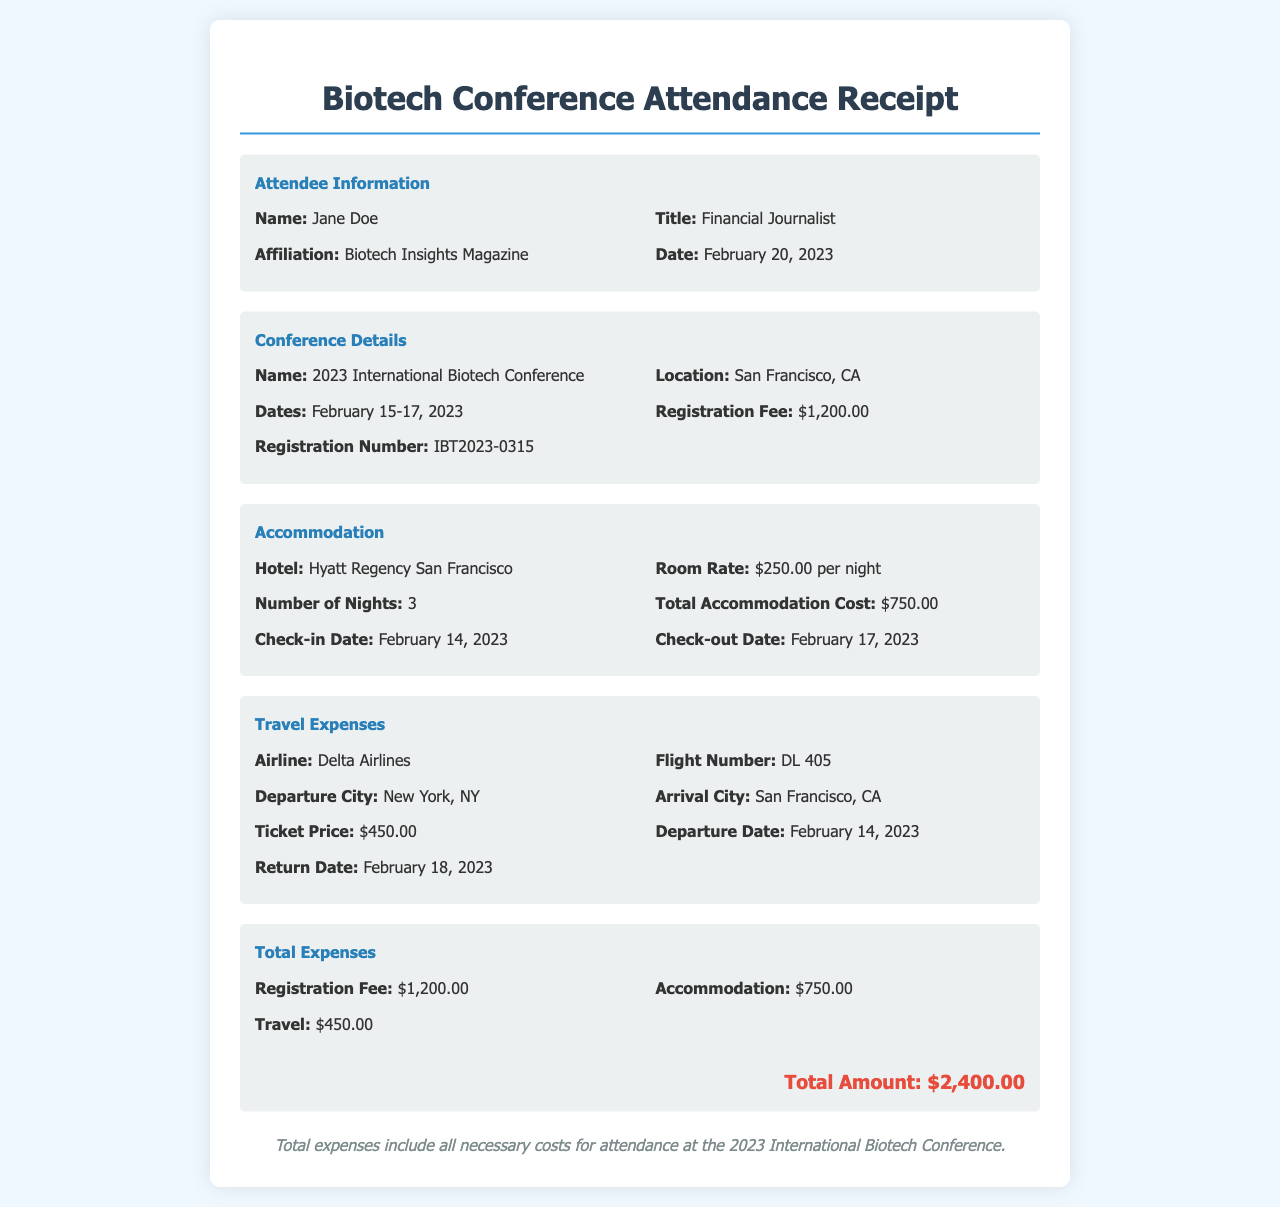what is the name of the conference? The conference is titled "2023 International Biotech Conference" as stated in the document.
Answer: 2023 International Biotech Conference who is the attendee? The attendee is Jane Doe, as mentioned in the attendee information section.
Answer: Jane Doe how much was the registration fee? The registration fee is specified as $1,200.00 in the conference details.
Answer: $1,200.00 what is the total cost of accommodation? The total cost of accommodation is detailed as $750.00 in the accommodation section.
Answer: $750.00 what is the airline for the travel? Delta Airlines is listed as the airline in the travel expenses section.
Answer: Delta Airlines what is the check-out date from the hotel? The check-out date is provided as February 17, 2023, under the accommodation section.
Answer: February 17, 2023 what are the total expenses incurred? The total expenses are calculated and presented at the bottom of the document as $2,400.00.
Answer: $2,400.00 how many nights was the accommodation? The document states that the number of nights was 3 in the accommodation section.
Answer: 3 what was the ticket price for the flight? The ticket price for the flight is mentioned as $450.00 in the travel expenses section.
Answer: $450.00 